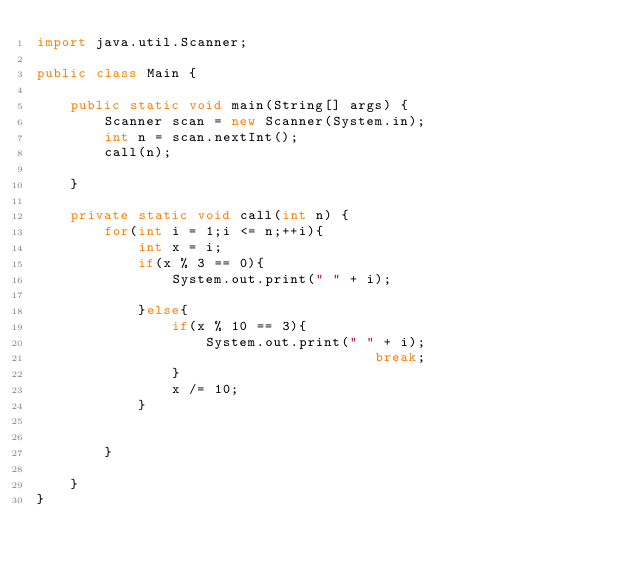Convert code to text. <code><loc_0><loc_0><loc_500><loc_500><_Java_>import java.util.Scanner;

public class Main {

	public static void main(String[] args) {
		Scanner scan = new Scanner(System.in);
		int n = scan.nextInt();
		call(n);

	}

	private static void call(int n) {
		for(int i = 1;i <= n;++i){
			int x = i;
			if(x % 3 == 0){
				System.out.print(" " + i);
 
			}else{
				if(x % 10 == 3){
					System.out.print(" " + i);
                                        break;
				}
				x /= 10;
			}


		}

	}
}</code> 